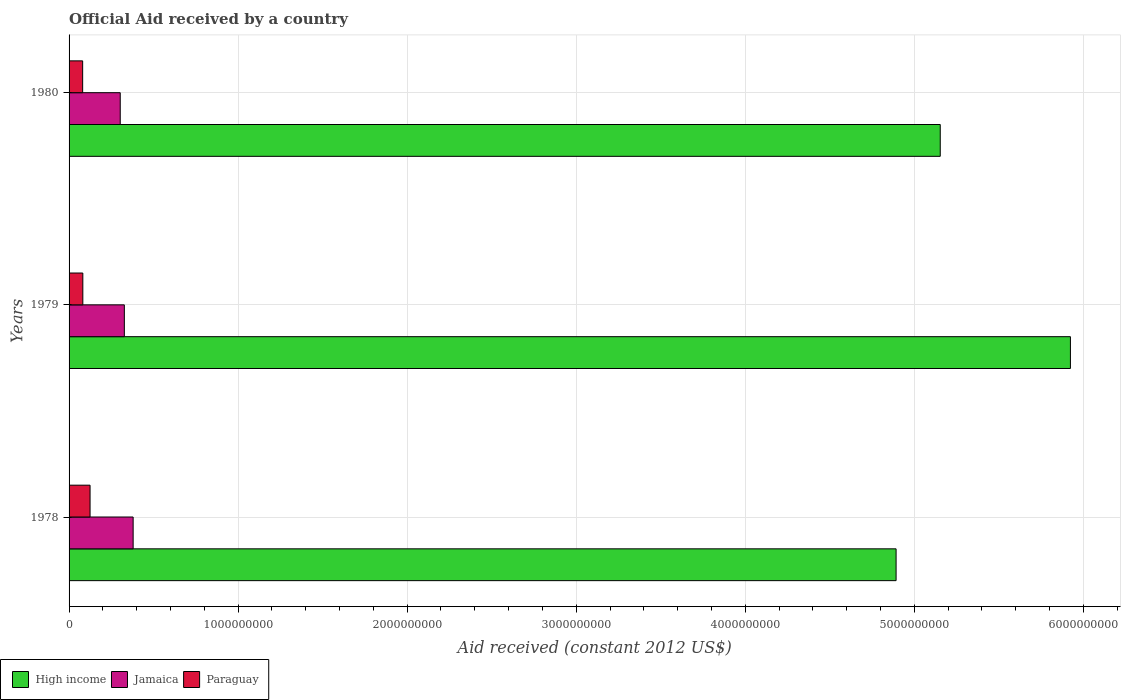Are the number of bars per tick equal to the number of legend labels?
Your answer should be very brief. Yes. How many bars are there on the 3rd tick from the top?
Your answer should be very brief. 3. How many bars are there on the 3rd tick from the bottom?
Ensure brevity in your answer.  3. What is the label of the 3rd group of bars from the top?
Offer a terse response. 1978. In how many cases, is the number of bars for a given year not equal to the number of legend labels?
Provide a short and direct response. 0. What is the net official aid received in Jamaica in 1978?
Ensure brevity in your answer.  3.79e+08. Across all years, what is the maximum net official aid received in Paraguay?
Keep it short and to the point. 1.24e+08. Across all years, what is the minimum net official aid received in Paraguay?
Make the answer very short. 8.04e+07. In which year was the net official aid received in Paraguay maximum?
Make the answer very short. 1978. In which year was the net official aid received in Paraguay minimum?
Your response must be concise. 1980. What is the total net official aid received in High income in the graph?
Your answer should be very brief. 1.60e+1. What is the difference between the net official aid received in Paraguay in 1979 and that in 1980?
Your response must be concise. 1.01e+06. What is the difference between the net official aid received in Jamaica in 1979 and the net official aid received in Paraguay in 1978?
Keep it short and to the point. 2.03e+08. What is the average net official aid received in Paraguay per year?
Keep it short and to the point. 9.53e+07. In the year 1980, what is the difference between the net official aid received in Paraguay and net official aid received in High income?
Your response must be concise. -5.07e+09. What is the ratio of the net official aid received in Jamaica in 1979 to that in 1980?
Offer a terse response. 1.08. Is the net official aid received in High income in 1978 less than that in 1980?
Keep it short and to the point. Yes. Is the difference between the net official aid received in Paraguay in 1978 and 1979 greater than the difference between the net official aid received in High income in 1978 and 1979?
Offer a very short reply. Yes. What is the difference between the highest and the second highest net official aid received in High income?
Your response must be concise. 7.70e+08. What is the difference between the highest and the lowest net official aid received in Jamaica?
Make the answer very short. 7.63e+07. In how many years, is the net official aid received in High income greater than the average net official aid received in High income taken over all years?
Give a very brief answer. 1. What does the 2nd bar from the top in 1979 represents?
Give a very brief answer. Jamaica. What does the 1st bar from the bottom in 1980 represents?
Your response must be concise. High income. Is it the case that in every year, the sum of the net official aid received in Paraguay and net official aid received in Jamaica is greater than the net official aid received in High income?
Make the answer very short. No. Are all the bars in the graph horizontal?
Make the answer very short. Yes. What is the difference between two consecutive major ticks on the X-axis?
Your answer should be compact. 1.00e+09. Are the values on the major ticks of X-axis written in scientific E-notation?
Provide a succinct answer. No. Does the graph contain grids?
Offer a very short reply. Yes. Where does the legend appear in the graph?
Make the answer very short. Bottom left. What is the title of the graph?
Offer a very short reply. Official Aid received by a country. What is the label or title of the X-axis?
Your answer should be compact. Aid received (constant 2012 US$). What is the Aid received (constant 2012 US$) in High income in 1978?
Offer a very short reply. 4.89e+09. What is the Aid received (constant 2012 US$) in Jamaica in 1978?
Offer a terse response. 3.79e+08. What is the Aid received (constant 2012 US$) of Paraguay in 1978?
Keep it short and to the point. 1.24e+08. What is the Aid received (constant 2012 US$) of High income in 1979?
Keep it short and to the point. 5.92e+09. What is the Aid received (constant 2012 US$) of Jamaica in 1979?
Ensure brevity in your answer.  3.27e+08. What is the Aid received (constant 2012 US$) in Paraguay in 1979?
Make the answer very short. 8.14e+07. What is the Aid received (constant 2012 US$) in High income in 1980?
Offer a very short reply. 5.15e+09. What is the Aid received (constant 2012 US$) in Jamaica in 1980?
Offer a very short reply. 3.03e+08. What is the Aid received (constant 2012 US$) in Paraguay in 1980?
Give a very brief answer. 8.04e+07. Across all years, what is the maximum Aid received (constant 2012 US$) in High income?
Your answer should be compact. 5.92e+09. Across all years, what is the maximum Aid received (constant 2012 US$) in Jamaica?
Provide a short and direct response. 3.79e+08. Across all years, what is the maximum Aid received (constant 2012 US$) of Paraguay?
Your answer should be compact. 1.24e+08. Across all years, what is the minimum Aid received (constant 2012 US$) of High income?
Make the answer very short. 4.89e+09. Across all years, what is the minimum Aid received (constant 2012 US$) of Jamaica?
Provide a succinct answer. 3.03e+08. Across all years, what is the minimum Aid received (constant 2012 US$) in Paraguay?
Keep it short and to the point. 8.04e+07. What is the total Aid received (constant 2012 US$) in High income in the graph?
Offer a terse response. 1.60e+1. What is the total Aid received (constant 2012 US$) in Jamaica in the graph?
Offer a very short reply. 1.01e+09. What is the total Aid received (constant 2012 US$) of Paraguay in the graph?
Provide a short and direct response. 2.86e+08. What is the difference between the Aid received (constant 2012 US$) of High income in 1978 and that in 1979?
Ensure brevity in your answer.  -1.03e+09. What is the difference between the Aid received (constant 2012 US$) in Jamaica in 1978 and that in 1979?
Your answer should be very brief. 5.20e+07. What is the difference between the Aid received (constant 2012 US$) of Paraguay in 1978 and that in 1979?
Provide a succinct answer. 4.28e+07. What is the difference between the Aid received (constant 2012 US$) of High income in 1978 and that in 1980?
Keep it short and to the point. -2.61e+08. What is the difference between the Aid received (constant 2012 US$) of Jamaica in 1978 and that in 1980?
Offer a very short reply. 7.63e+07. What is the difference between the Aid received (constant 2012 US$) of Paraguay in 1978 and that in 1980?
Keep it short and to the point. 4.38e+07. What is the difference between the Aid received (constant 2012 US$) of High income in 1979 and that in 1980?
Your response must be concise. 7.70e+08. What is the difference between the Aid received (constant 2012 US$) of Jamaica in 1979 and that in 1980?
Provide a short and direct response. 2.42e+07. What is the difference between the Aid received (constant 2012 US$) in Paraguay in 1979 and that in 1980?
Your answer should be very brief. 1.01e+06. What is the difference between the Aid received (constant 2012 US$) in High income in 1978 and the Aid received (constant 2012 US$) in Jamaica in 1979?
Provide a short and direct response. 4.57e+09. What is the difference between the Aid received (constant 2012 US$) of High income in 1978 and the Aid received (constant 2012 US$) of Paraguay in 1979?
Your answer should be very brief. 4.81e+09. What is the difference between the Aid received (constant 2012 US$) in Jamaica in 1978 and the Aid received (constant 2012 US$) in Paraguay in 1979?
Keep it short and to the point. 2.98e+08. What is the difference between the Aid received (constant 2012 US$) of High income in 1978 and the Aid received (constant 2012 US$) of Jamaica in 1980?
Provide a short and direct response. 4.59e+09. What is the difference between the Aid received (constant 2012 US$) in High income in 1978 and the Aid received (constant 2012 US$) in Paraguay in 1980?
Provide a short and direct response. 4.81e+09. What is the difference between the Aid received (constant 2012 US$) in Jamaica in 1978 and the Aid received (constant 2012 US$) in Paraguay in 1980?
Ensure brevity in your answer.  2.99e+08. What is the difference between the Aid received (constant 2012 US$) in High income in 1979 and the Aid received (constant 2012 US$) in Jamaica in 1980?
Provide a short and direct response. 5.62e+09. What is the difference between the Aid received (constant 2012 US$) of High income in 1979 and the Aid received (constant 2012 US$) of Paraguay in 1980?
Offer a terse response. 5.84e+09. What is the difference between the Aid received (constant 2012 US$) in Jamaica in 1979 and the Aid received (constant 2012 US$) in Paraguay in 1980?
Keep it short and to the point. 2.47e+08. What is the average Aid received (constant 2012 US$) of High income per year?
Offer a very short reply. 5.32e+09. What is the average Aid received (constant 2012 US$) in Jamaica per year?
Make the answer very short. 3.36e+08. What is the average Aid received (constant 2012 US$) of Paraguay per year?
Make the answer very short. 9.53e+07. In the year 1978, what is the difference between the Aid received (constant 2012 US$) in High income and Aid received (constant 2012 US$) in Jamaica?
Provide a short and direct response. 4.51e+09. In the year 1978, what is the difference between the Aid received (constant 2012 US$) in High income and Aid received (constant 2012 US$) in Paraguay?
Provide a succinct answer. 4.77e+09. In the year 1978, what is the difference between the Aid received (constant 2012 US$) in Jamaica and Aid received (constant 2012 US$) in Paraguay?
Your answer should be very brief. 2.55e+08. In the year 1979, what is the difference between the Aid received (constant 2012 US$) of High income and Aid received (constant 2012 US$) of Jamaica?
Ensure brevity in your answer.  5.60e+09. In the year 1979, what is the difference between the Aid received (constant 2012 US$) of High income and Aid received (constant 2012 US$) of Paraguay?
Your response must be concise. 5.84e+09. In the year 1979, what is the difference between the Aid received (constant 2012 US$) of Jamaica and Aid received (constant 2012 US$) of Paraguay?
Keep it short and to the point. 2.46e+08. In the year 1980, what is the difference between the Aid received (constant 2012 US$) in High income and Aid received (constant 2012 US$) in Jamaica?
Offer a very short reply. 4.85e+09. In the year 1980, what is the difference between the Aid received (constant 2012 US$) of High income and Aid received (constant 2012 US$) of Paraguay?
Offer a terse response. 5.07e+09. In the year 1980, what is the difference between the Aid received (constant 2012 US$) in Jamaica and Aid received (constant 2012 US$) in Paraguay?
Keep it short and to the point. 2.22e+08. What is the ratio of the Aid received (constant 2012 US$) of High income in 1978 to that in 1979?
Offer a terse response. 0.83. What is the ratio of the Aid received (constant 2012 US$) of Jamaica in 1978 to that in 1979?
Offer a terse response. 1.16. What is the ratio of the Aid received (constant 2012 US$) in Paraguay in 1978 to that in 1979?
Your response must be concise. 1.53. What is the ratio of the Aid received (constant 2012 US$) in High income in 1978 to that in 1980?
Keep it short and to the point. 0.95. What is the ratio of the Aid received (constant 2012 US$) in Jamaica in 1978 to that in 1980?
Make the answer very short. 1.25. What is the ratio of the Aid received (constant 2012 US$) of Paraguay in 1978 to that in 1980?
Your response must be concise. 1.54. What is the ratio of the Aid received (constant 2012 US$) in High income in 1979 to that in 1980?
Ensure brevity in your answer.  1.15. What is the ratio of the Aid received (constant 2012 US$) of Jamaica in 1979 to that in 1980?
Your response must be concise. 1.08. What is the ratio of the Aid received (constant 2012 US$) in Paraguay in 1979 to that in 1980?
Offer a terse response. 1.01. What is the difference between the highest and the second highest Aid received (constant 2012 US$) in High income?
Your answer should be very brief. 7.70e+08. What is the difference between the highest and the second highest Aid received (constant 2012 US$) of Jamaica?
Your answer should be very brief. 5.20e+07. What is the difference between the highest and the second highest Aid received (constant 2012 US$) in Paraguay?
Your response must be concise. 4.28e+07. What is the difference between the highest and the lowest Aid received (constant 2012 US$) in High income?
Ensure brevity in your answer.  1.03e+09. What is the difference between the highest and the lowest Aid received (constant 2012 US$) in Jamaica?
Offer a very short reply. 7.63e+07. What is the difference between the highest and the lowest Aid received (constant 2012 US$) in Paraguay?
Provide a short and direct response. 4.38e+07. 